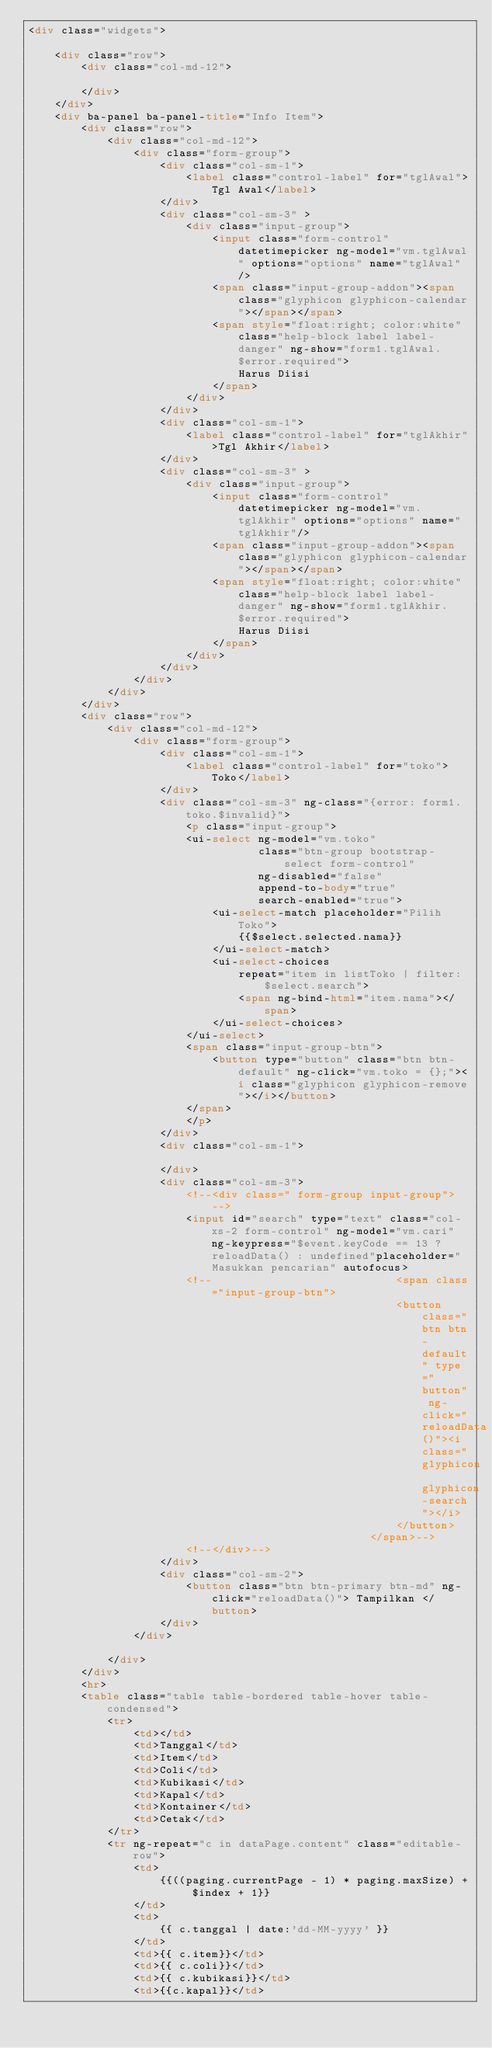<code> <loc_0><loc_0><loc_500><loc_500><_HTML_><div class="widgets">

    <div class="row">
        <div class="col-md-12">

        </div>
    </div>
    <div ba-panel ba-panel-title="Info Item">
        <div class="row">
            <div class="col-md-12">
                <div class="form-group">
                    <div class="col-sm-1">
                        <label class="control-label" for="tglAwal">Tgl Awal</label>
                    </div>
                    <div class="col-sm-3" >
                        <div class="input-group">
                            <input class="form-control" datetimepicker ng-model="vm.tglAwal" options="options" name="tglAwal"/>
                            <span class="input-group-addon"><span class="glyphicon glyphicon-calendar"></span></span>
                            <span style="float:right; color:white" class="help-block label label-danger" ng-show="form1.tglAwal.$error.required">
                                Harus Diisi
                            </span>                        
                        </div>
                    </div>
                    <div class="col-sm-1">
                        <label class="control-label" for="tglAkhir">Tgl Akhir</label>
                    </div>
                    <div class="col-sm-3" >
                        <div class="input-group">
                            <input class="form-control" datetimepicker ng-model="vm.tglAkhir" options="options" name="tglAkhir"/>
                            <span class="input-group-addon"><span class="glyphicon glyphicon-calendar"></span></span>
                            <span style="float:right; color:white" class="help-block label label-danger" ng-show="form1.tglAkhir.$error.required">
                                Harus Diisi
                            </span>                        
                        </div>                        
                    </div>
                </div>
            </div>
        </div>
        <div class="row">
            <div class="col-md-12">
                <div class="form-group">
                    <div class="col-sm-1">
                        <label class="control-label" for="toko">Toko</label>
                    </div>
                    <div class="col-sm-3" ng-class="{error: form1.toko.$invalid}">
                        <p class="input-group">
                        <ui-select ng-model="vm.toko"
                                   class="btn-group bootstrap-select form-control"
                                   ng-disabled="false"
                                   append-to-body="true"
                                   search-enabled="true">
                            <ui-select-match placeholder="Pilih Toko">
                                {{$select.selected.nama}}
                            </ui-select-match>
                            <ui-select-choices
                                repeat="item in listToko | filter: $select.search">
                                <span ng-bind-html="item.nama"></span>
                            </ui-select-choices>
                        </ui-select>
                        <span class="input-group-btn">
                            <button type="button" class="btn btn-default" ng-click="vm.toko = {};"><i class="glyphicon glyphicon-remove"></i></button>
                        </span>
                        </p>
                    </div>
                    <div class="col-sm-1">

                    </div>
                    <div class="col-sm-3">
                        <!--<div class=" form-group input-group">-->
                        <input id="search" type="text" class="col-xs-2 form-control" ng-model="vm.cari" ng-keypress="$event.keyCode == 13 ? reloadData() : undefined"placeholder="Masukkan pencarian" autofocus>
                        <!--                            <span class="input-group-btn">
                                                        <button class="btn btn-default" type="button" ng-click="reloadData()"><i class="glyphicon glyphicon-search"></i>
                                                        </button>
                                                    </span>-->
                        <!--</div>-->
                    </div>
                    <div class="col-sm-2">
                        <button class="btn btn-primary btn-md" ng-click="reloadData()"> Tampilkan </button>
                    </div>
                </div>

            </div>
        </div>
        <hr>
        <table class="table table-bordered table-hover table-condensed">
            <tr>
                <td></td>
                <td>Tanggal</td>
                <td>Item</td>
                <td>Coli</td>
                <td>Kubikasi</td>
                <td>Kapal</td>
                <td>Kontainer</td>                
                <td>Cetak</td>                
            </tr>
            <tr ng-repeat="c in dataPage.content" class="editable-row">
                <td>
                    {{((paging.currentPage - 1) * paging.maxSize) + $index + 1}}
                </td>
                <td>
                    {{ c.tanggal | date:'dd-MM-yyyy' }}
                </td>
                <td>{{ c.item}}</td>
                <td>{{ c.coli}}</td>
                <td>{{ c.kubikasi}}</td>
                <td>{{c.kapal}}</td></code> 